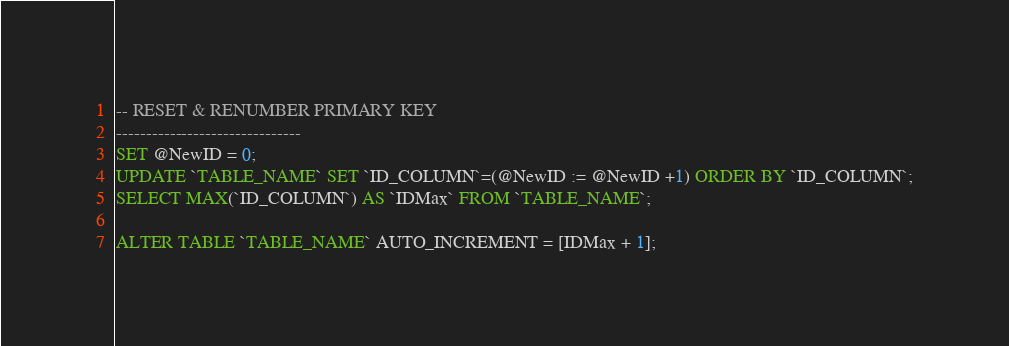Convert code to text. <code><loc_0><loc_0><loc_500><loc_500><_SQL_>-- RESET & RENUMBER PRIMARY KEY
-------------------------------
SET @NewID = 0;
UPDATE `TABLE_NAME` SET `ID_COLUMN`=(@NewID := @NewID +1) ORDER BY `ID_COLUMN`;
SELECT MAX(`ID_COLUMN`) AS `IDMax` FROM `TABLE_NAME`;

ALTER TABLE `TABLE_NAME` AUTO_INCREMENT = [IDMax + 1];

</code> 